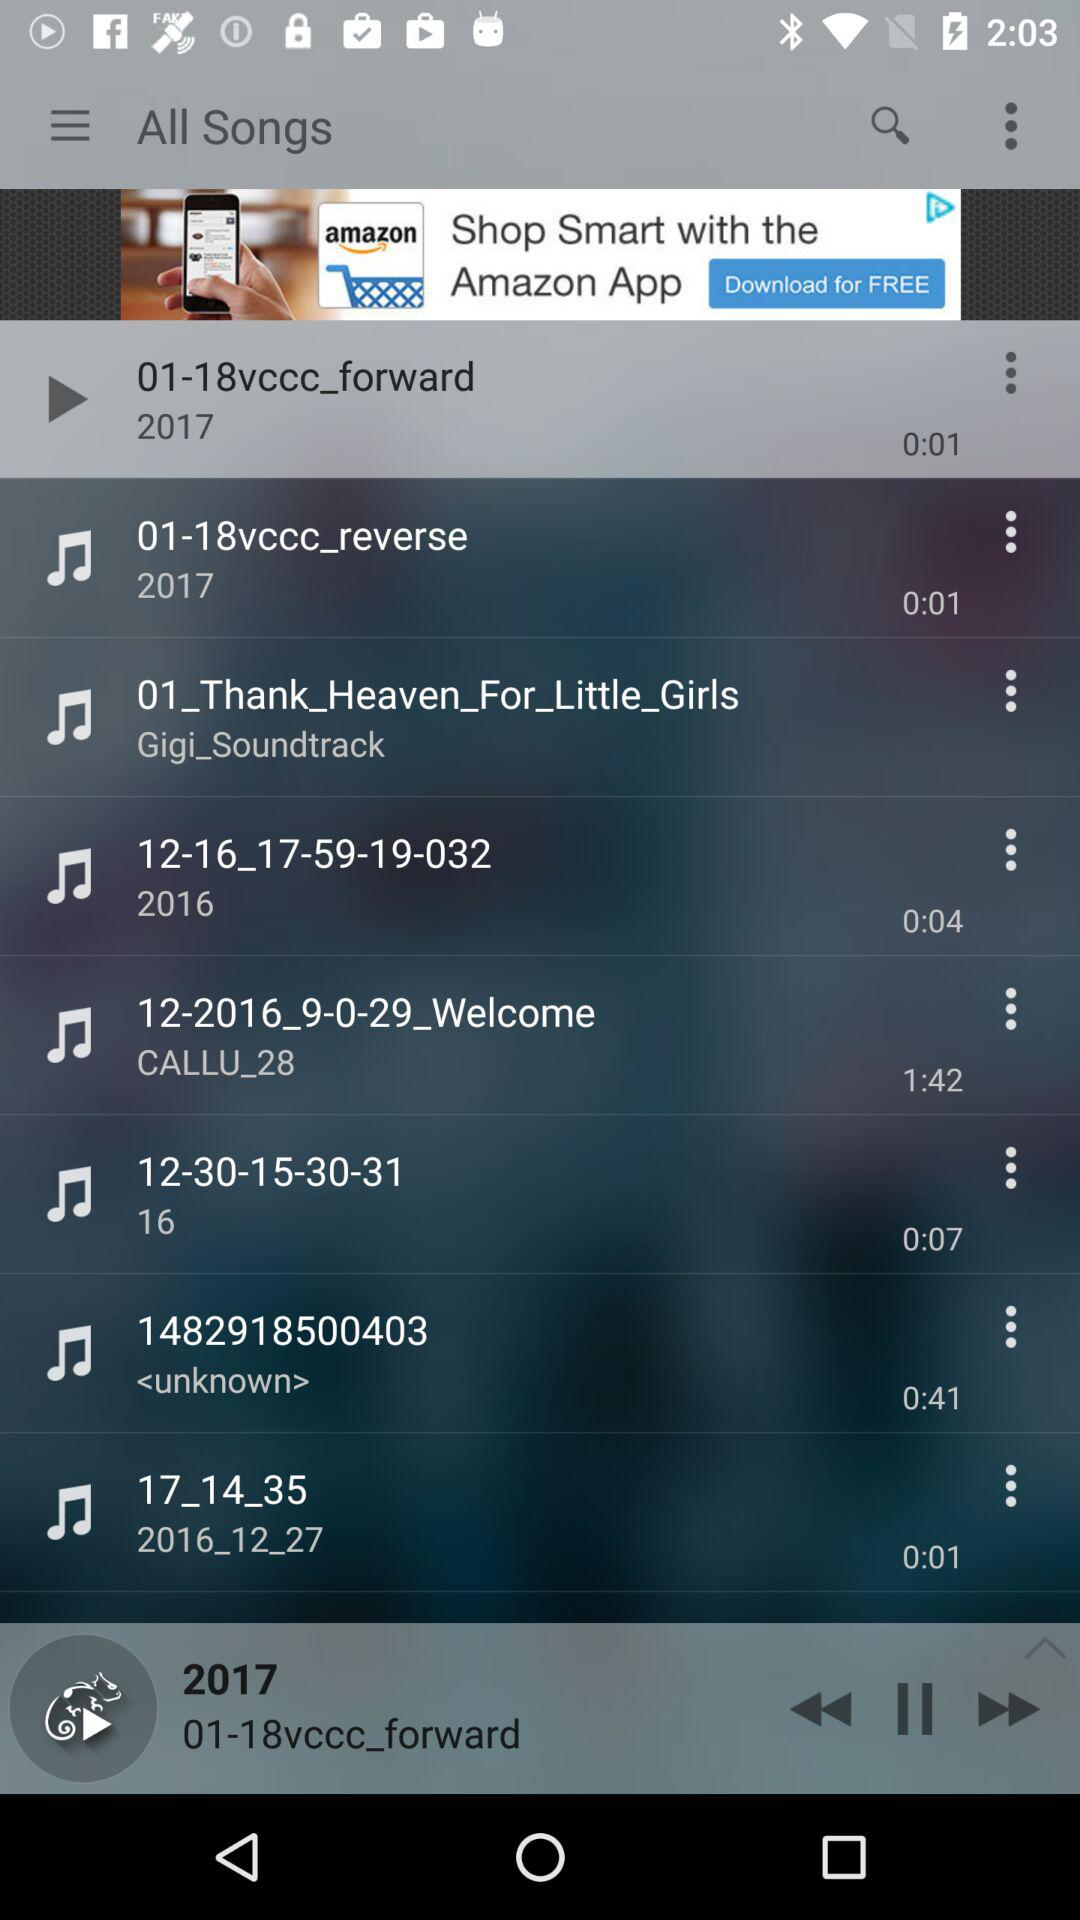Which options are available to share the song with friends?
When the provided information is insufficient, respond with <no answer>. <no answer> 